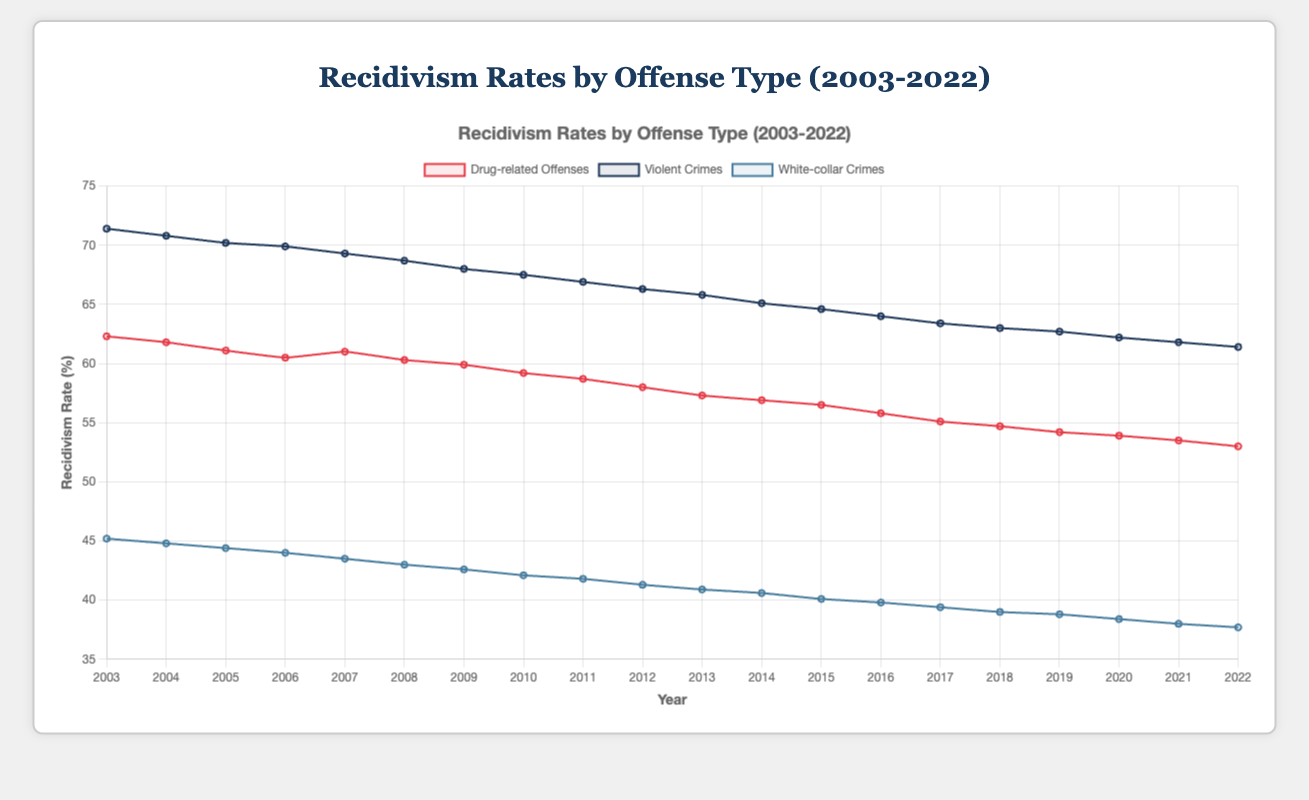Which type of offenses had the highest recidivism rate in 2003? By looking at the lines on the plot and identifying the highest point for the year 2003, the line for violent crimes is at the top with a rate of 71.4%.
Answer: Violent crimes How did the recidivism rate for drug-related offenses in 2005 compare to white-collar crimes in the same year? In 2005, the recidivism rate for drug-related offenses was 61.1%, while for white-collar crimes it was 44.4%. Comparing these, drug-related offenses had a higher rate.
Answer: Drug-related offenses had a higher rate What is the overall trend for recidivism rates of violent crimes from 2003 to 2022? Observing the line representing violent crimes from 2003 to 2022, it shows a consistent decline from 71.4% to 61.4%.
Answer: Decreasing trend Which type of offenses had the most significant decrease in recidivism rates over the 20 years? By comparing the starting and ending points of all the lines, white-collar crimes decreased from 45.2% to 37.7%, which is a decrease of 7.5 percentage points, the largest among the three offense types.
Answer: White-collar crimes What was the approximate difference in recidivism rates between drug-related offenses and violent crimes in 2014? The recidivism rate for drug-related offenses in 2014 was 56.9%, and for violent crimes it was 65.1%. The difference between these two rates is 65.1% - 56.9% = 8.2%.
Answer: 8.2% Which year had the lowest recidivism rate for white-collar crimes? By observing the lowest point on the line for white-collar crimes, the rate in the year 2022 was 37.7%, which is the lowest point in the entire range from 2003 to 2022.
Answer: 2022 How does the recidivism rate for violent crimes in 2020 compare to the rate for drug-related offenses in the same year? The recidivism rate for violent crimes in 2020 was 62.2%, while for drug-related offenses it was 53.9%. Comparing these, violent crimes had a higher rate.
Answer: Violent crimes had a higher rate What is the average recidivism rate for drug-related offenses over the entire period? The sum of the recidivism rates for drug-related offenses is 1,112.4 (adding all annual data points). The number of years is 20. The average rate is 1,112.4 / 20 = 55.62%.
Answer: 55.62% Did the recidivism rate for white-collar crimes ever exceed 50% during the 20-year period? By examining the plot for the white-collar crimes line, its highest starting point is at 45.2% in 2003. Since it never reaches or exceeds 50% in any year as per the data, the answer is no.
Answer: No What is the difference in recidivism rates between white-collar crimes and violent crimes in 2022? The recidivism rate for white-collar crimes in 2022 was 37.7%, and for violent crimes it was 61.4%. The difference between these rates is 61.4% - 37.7% = 23.7%.
Answer: 23.7% 